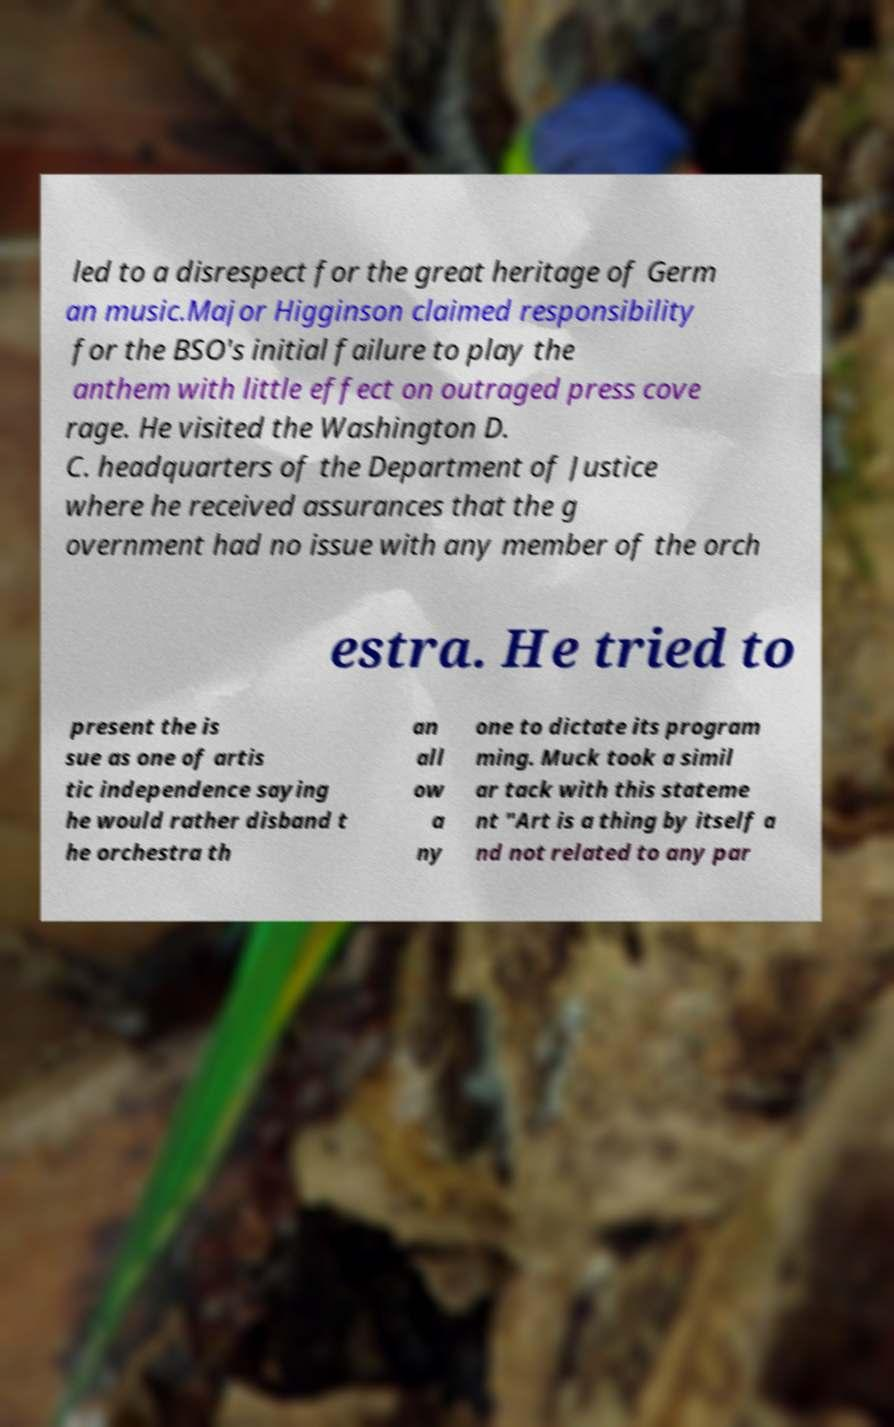Could you assist in decoding the text presented in this image and type it out clearly? led to a disrespect for the great heritage of Germ an music.Major Higginson claimed responsibility for the BSO's initial failure to play the anthem with little effect on outraged press cove rage. He visited the Washington D. C. headquarters of the Department of Justice where he received assurances that the g overnment had no issue with any member of the orch estra. He tried to present the is sue as one of artis tic independence saying he would rather disband t he orchestra th an all ow a ny one to dictate its program ming. Muck took a simil ar tack with this stateme nt "Art is a thing by itself a nd not related to any par 